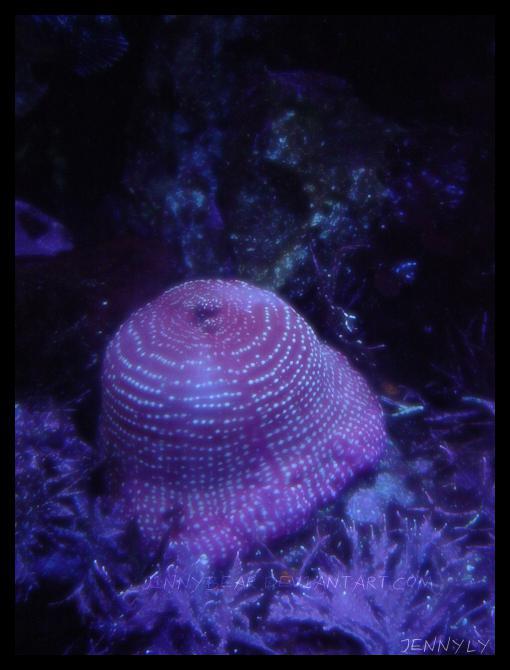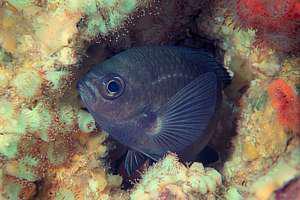The first image is the image on the left, the second image is the image on the right. Given the left and right images, does the statement "In both pictures a clownfish is swimming in a sea anemone." hold true? Answer yes or no. No. The first image is the image on the left, the second image is the image on the right. Evaluate the accuracy of this statement regarding the images: "At least one image features a striped fish atop a purplish-blue anemone.". Is it true? Answer yes or no. No. 